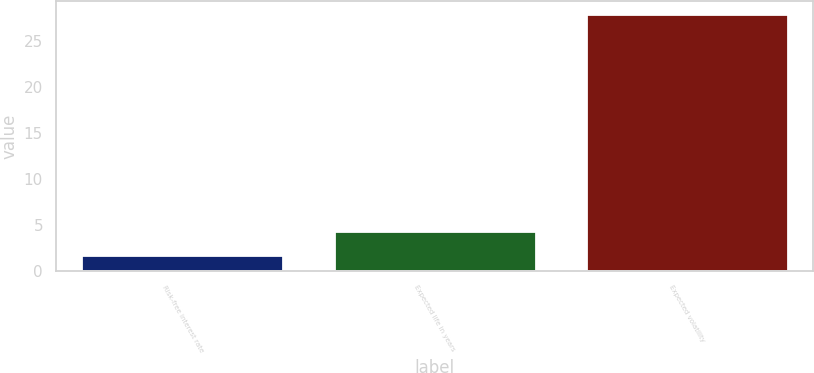Convert chart. <chart><loc_0><loc_0><loc_500><loc_500><bar_chart><fcel>Risk-free interest rate<fcel>Expected life in years<fcel>Expected volatility<nl><fcel>1.73<fcel>4.36<fcel>28<nl></chart> 